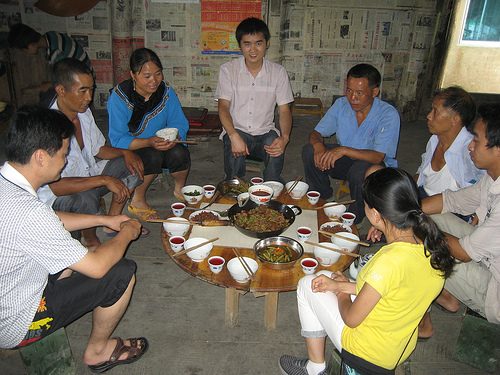<image>
Is the man to the left of the woman? Yes. From this viewpoint, the man is positioned to the left side relative to the woman. Is the chopsticks in the bowl? Yes. The chopsticks is contained within or inside the bowl, showing a containment relationship. Where is the food in relation to the wall? Is it in the wall? No. The food is not contained within the wall. These objects have a different spatial relationship. 